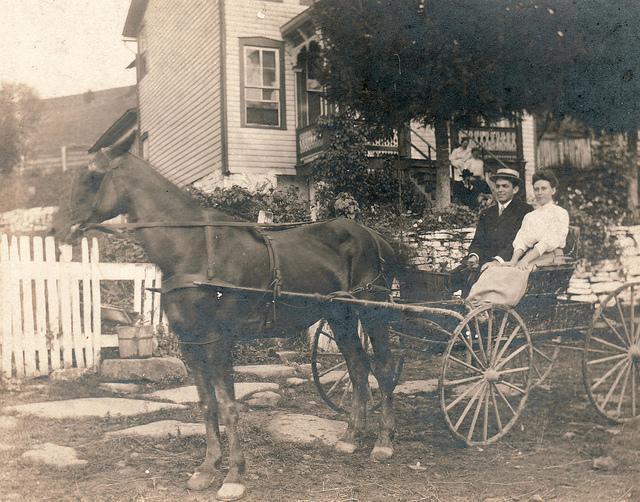How many women are wearing a hat?
Give a very brief answer. 0. How many people are in the picture?
Give a very brief answer. 2. How many dogs are wearing a leash?
Give a very brief answer. 0. 